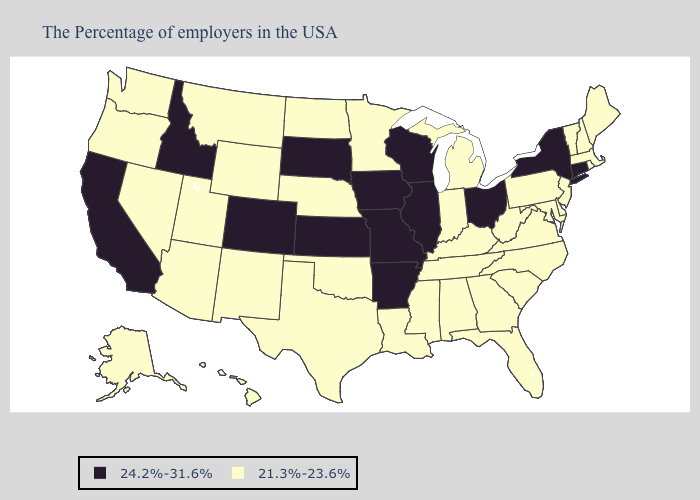Does Arkansas have the lowest value in the South?
Concise answer only. No. What is the value of Kansas?
Short answer required. 24.2%-31.6%. Among the states that border Minnesota , does North Dakota have the lowest value?
Concise answer only. Yes. Does Oregon have the highest value in the West?
Be succinct. No. Which states have the lowest value in the West?
Answer briefly. Wyoming, New Mexico, Utah, Montana, Arizona, Nevada, Washington, Oregon, Alaska, Hawaii. What is the value of North Carolina?
Be succinct. 21.3%-23.6%. Does Arkansas have a higher value than Alabama?
Answer briefly. Yes. Name the states that have a value in the range 21.3%-23.6%?
Give a very brief answer. Maine, Massachusetts, Rhode Island, New Hampshire, Vermont, New Jersey, Delaware, Maryland, Pennsylvania, Virginia, North Carolina, South Carolina, West Virginia, Florida, Georgia, Michigan, Kentucky, Indiana, Alabama, Tennessee, Mississippi, Louisiana, Minnesota, Nebraska, Oklahoma, Texas, North Dakota, Wyoming, New Mexico, Utah, Montana, Arizona, Nevada, Washington, Oregon, Alaska, Hawaii. Does the map have missing data?
Concise answer only. No. How many symbols are there in the legend?
Concise answer only. 2. Does Illinois have a higher value than Wisconsin?
Short answer required. No. Does Idaho have the highest value in the West?
Give a very brief answer. Yes. Which states have the lowest value in the USA?
Give a very brief answer. Maine, Massachusetts, Rhode Island, New Hampshire, Vermont, New Jersey, Delaware, Maryland, Pennsylvania, Virginia, North Carolina, South Carolina, West Virginia, Florida, Georgia, Michigan, Kentucky, Indiana, Alabama, Tennessee, Mississippi, Louisiana, Minnesota, Nebraska, Oklahoma, Texas, North Dakota, Wyoming, New Mexico, Utah, Montana, Arizona, Nevada, Washington, Oregon, Alaska, Hawaii. Name the states that have a value in the range 24.2%-31.6%?
Keep it brief. Connecticut, New York, Ohio, Wisconsin, Illinois, Missouri, Arkansas, Iowa, Kansas, South Dakota, Colorado, Idaho, California. 